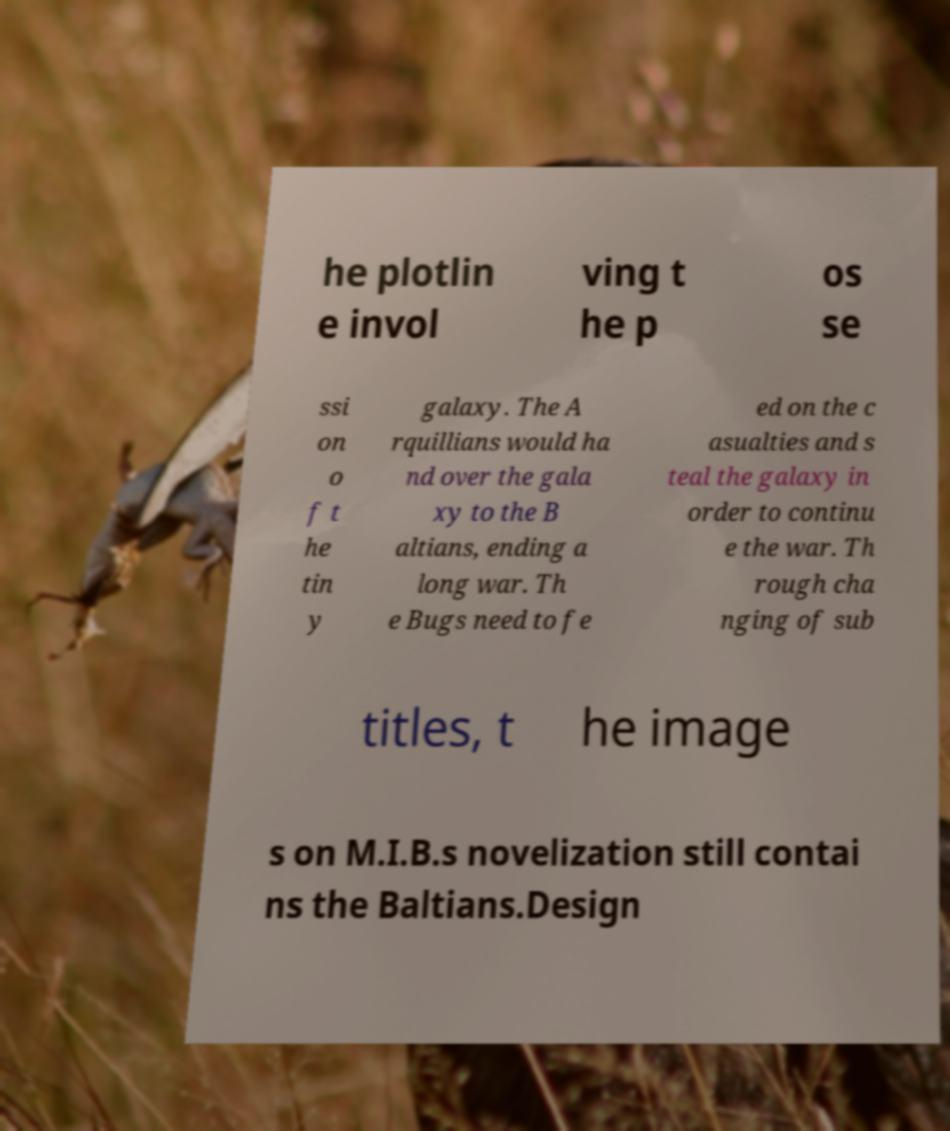Please read and relay the text visible in this image. What does it say? he plotlin e invol ving t he p os se ssi on o f t he tin y galaxy. The A rquillians would ha nd over the gala xy to the B altians, ending a long war. Th e Bugs need to fe ed on the c asualties and s teal the galaxy in order to continu e the war. Th rough cha nging of sub titles, t he image s on M.I.B.s novelization still contai ns the Baltians.Design 